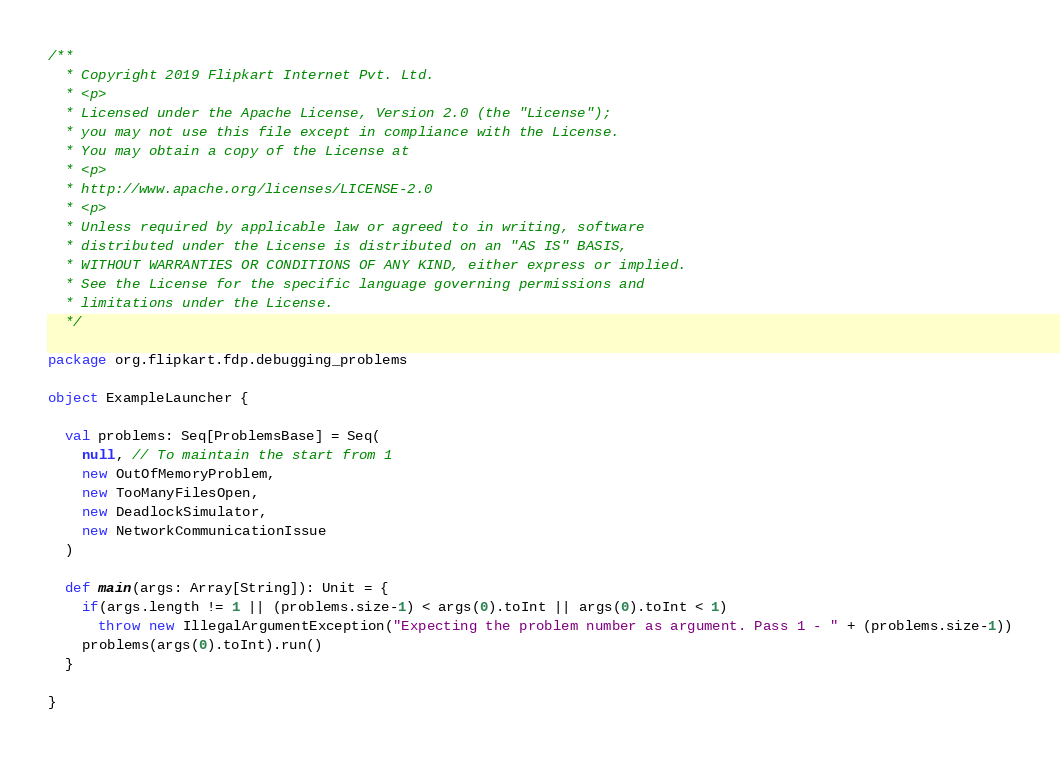<code> <loc_0><loc_0><loc_500><loc_500><_Scala_>/**
  * Copyright 2019 Flipkart Internet Pvt. Ltd.
  * <p>
  * Licensed under the Apache License, Version 2.0 (the "License");
  * you may not use this file except in compliance with the License.
  * You may obtain a copy of the License at
  * <p>
  * http://www.apache.org/licenses/LICENSE-2.0
  * <p>
  * Unless required by applicable law or agreed to in writing, software
  * distributed under the License is distributed on an "AS IS" BASIS,
  * WITHOUT WARRANTIES OR CONDITIONS OF ANY KIND, either express or implied.
  * See the License for the specific language governing permissions and
  * limitations under the License.
  */

package org.flipkart.fdp.debugging_problems

object ExampleLauncher {

  val problems: Seq[ProblemsBase] = Seq(
    null, // To maintain the start from 1
    new OutOfMemoryProblem,
    new TooManyFilesOpen,
    new DeadlockSimulator,
    new NetworkCommunicationIssue
  )

  def main(args: Array[String]): Unit = {
    if(args.length != 1 || (problems.size-1) < args(0).toInt || args(0).toInt < 1)
      throw new IllegalArgumentException("Expecting the problem number as argument. Pass 1 - " + (problems.size-1))
    problems(args(0).toInt).run()
  }

}
</code> 